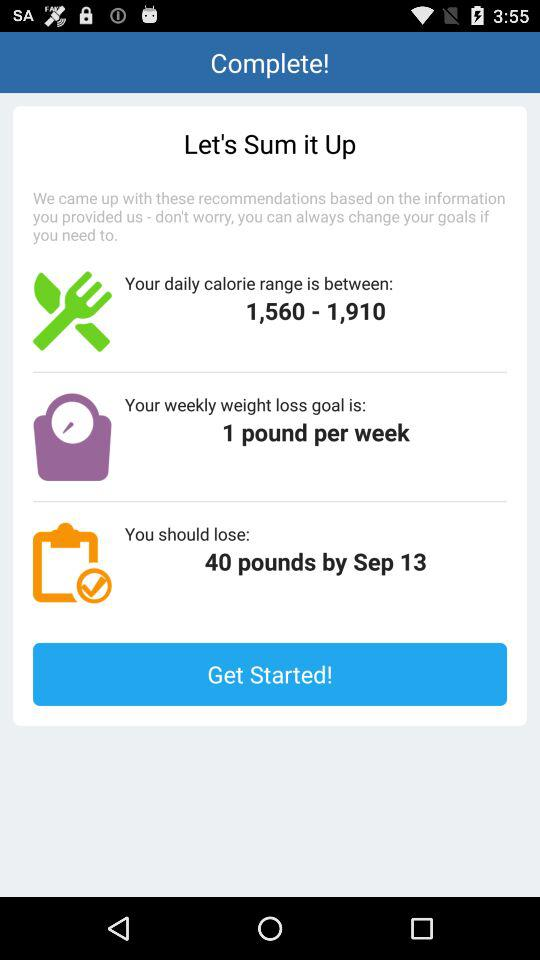How much weight to lose? The weight that has to be lose is 1 pound per week. 